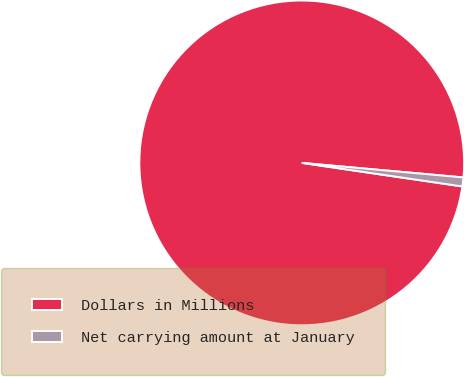<chart> <loc_0><loc_0><loc_500><loc_500><pie_chart><fcel>Dollars in Millions<fcel>Net carrying amount at January<nl><fcel>99.11%<fcel>0.89%<nl></chart> 